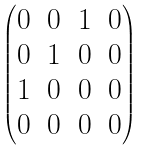<formula> <loc_0><loc_0><loc_500><loc_500>\begin{pmatrix} 0 & 0 & 1 & 0 \\ 0 & 1 & 0 & 0 \\ 1 & 0 & 0 & 0 \\ 0 & 0 & 0 & 0 \end{pmatrix}</formula> 